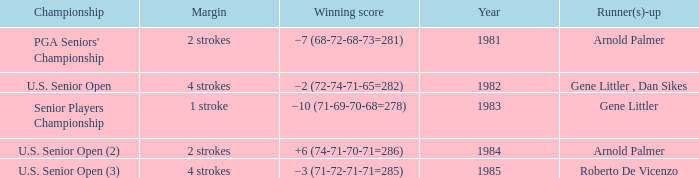What margin was in after 1981, and was Roberto De Vicenzo runner-up? 4 strokes. 